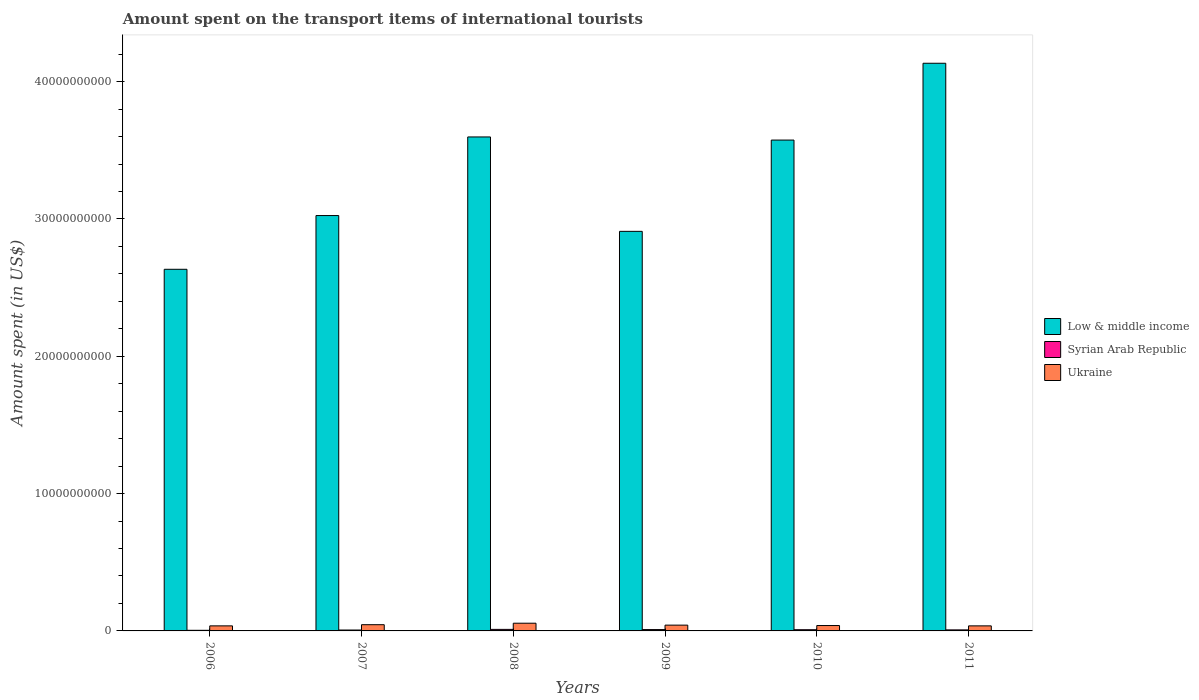Are the number of bars per tick equal to the number of legend labels?
Your response must be concise. Yes. What is the label of the 1st group of bars from the left?
Your response must be concise. 2006. In how many cases, is the number of bars for a given year not equal to the number of legend labels?
Make the answer very short. 0. What is the amount spent on the transport items of international tourists in Low & middle income in 2006?
Give a very brief answer. 2.63e+1. Across all years, what is the maximum amount spent on the transport items of international tourists in Syrian Arab Republic?
Provide a succinct answer. 1.12e+08. Across all years, what is the minimum amount spent on the transport items of international tourists in Ukraine?
Offer a terse response. 3.68e+08. What is the total amount spent on the transport items of international tourists in Ukraine in the graph?
Make the answer very short. 2.56e+09. What is the difference between the amount spent on the transport items of international tourists in Ukraine in 2006 and that in 2009?
Provide a short and direct response. -5.30e+07. What is the difference between the amount spent on the transport items of international tourists in Ukraine in 2008 and the amount spent on the transport items of international tourists in Syrian Arab Republic in 2009?
Make the answer very short. 4.64e+08. What is the average amount spent on the transport items of international tourists in Low & middle income per year?
Your answer should be very brief. 3.31e+1. In the year 2011, what is the difference between the amount spent on the transport items of international tourists in Ukraine and amount spent on the transport items of international tourists in Low & middle income?
Offer a terse response. -4.10e+1. What is the ratio of the amount spent on the transport items of international tourists in Ukraine in 2007 to that in 2009?
Offer a very short reply. 1.08. What is the difference between the highest and the second highest amount spent on the transport items of international tourists in Syrian Arab Republic?
Provide a short and direct response. 1.40e+07. What is the difference between the highest and the lowest amount spent on the transport items of international tourists in Low & middle income?
Provide a short and direct response. 1.50e+1. In how many years, is the amount spent on the transport items of international tourists in Ukraine greater than the average amount spent on the transport items of international tourists in Ukraine taken over all years?
Offer a very short reply. 2. Is the sum of the amount spent on the transport items of international tourists in Syrian Arab Republic in 2008 and 2009 greater than the maximum amount spent on the transport items of international tourists in Ukraine across all years?
Offer a very short reply. No. What does the 1st bar from the left in 2007 represents?
Give a very brief answer. Low & middle income. What does the 2nd bar from the right in 2011 represents?
Make the answer very short. Syrian Arab Republic. What is the difference between two consecutive major ticks on the Y-axis?
Provide a succinct answer. 1.00e+1. Are the values on the major ticks of Y-axis written in scientific E-notation?
Ensure brevity in your answer.  No. Does the graph contain any zero values?
Give a very brief answer. No. Where does the legend appear in the graph?
Offer a terse response. Center right. What is the title of the graph?
Keep it short and to the point. Amount spent on the transport items of international tourists. Does "Colombia" appear as one of the legend labels in the graph?
Ensure brevity in your answer.  No. What is the label or title of the Y-axis?
Provide a short and direct response. Amount spent (in US$). What is the Amount spent (in US$) in Low & middle income in 2006?
Your answer should be compact. 2.63e+1. What is the Amount spent (in US$) of Syrian Arab Republic in 2006?
Your response must be concise. 4.50e+07. What is the Amount spent (in US$) in Ukraine in 2006?
Your response must be concise. 3.68e+08. What is the Amount spent (in US$) of Low & middle income in 2007?
Offer a terse response. 3.02e+1. What is the Amount spent (in US$) in Syrian Arab Republic in 2007?
Keep it short and to the point. 6.50e+07. What is the Amount spent (in US$) of Ukraine in 2007?
Your response must be concise. 4.53e+08. What is the Amount spent (in US$) in Low & middle income in 2008?
Provide a succinct answer. 3.60e+1. What is the Amount spent (in US$) in Syrian Arab Republic in 2008?
Make the answer very short. 1.12e+08. What is the Amount spent (in US$) in Ukraine in 2008?
Provide a short and direct response. 5.62e+08. What is the Amount spent (in US$) of Low & middle income in 2009?
Provide a succinct answer. 2.91e+1. What is the Amount spent (in US$) in Syrian Arab Republic in 2009?
Give a very brief answer. 9.80e+07. What is the Amount spent (in US$) in Ukraine in 2009?
Give a very brief answer. 4.21e+08. What is the Amount spent (in US$) of Low & middle income in 2010?
Make the answer very short. 3.57e+1. What is the Amount spent (in US$) in Syrian Arab Republic in 2010?
Your response must be concise. 8.80e+07. What is the Amount spent (in US$) in Ukraine in 2010?
Provide a succinct answer. 3.92e+08. What is the Amount spent (in US$) in Low & middle income in 2011?
Ensure brevity in your answer.  4.13e+1. What is the Amount spent (in US$) of Syrian Arab Republic in 2011?
Offer a very short reply. 7.60e+07. What is the Amount spent (in US$) in Ukraine in 2011?
Make the answer very short. 3.68e+08. Across all years, what is the maximum Amount spent (in US$) in Low & middle income?
Your answer should be very brief. 4.13e+1. Across all years, what is the maximum Amount spent (in US$) in Syrian Arab Republic?
Give a very brief answer. 1.12e+08. Across all years, what is the maximum Amount spent (in US$) of Ukraine?
Your answer should be very brief. 5.62e+08. Across all years, what is the minimum Amount spent (in US$) of Low & middle income?
Give a very brief answer. 2.63e+1. Across all years, what is the minimum Amount spent (in US$) in Syrian Arab Republic?
Provide a succinct answer. 4.50e+07. Across all years, what is the minimum Amount spent (in US$) in Ukraine?
Your answer should be compact. 3.68e+08. What is the total Amount spent (in US$) of Low & middle income in the graph?
Give a very brief answer. 1.99e+11. What is the total Amount spent (in US$) of Syrian Arab Republic in the graph?
Your response must be concise. 4.84e+08. What is the total Amount spent (in US$) in Ukraine in the graph?
Ensure brevity in your answer.  2.56e+09. What is the difference between the Amount spent (in US$) in Low & middle income in 2006 and that in 2007?
Your answer should be very brief. -3.91e+09. What is the difference between the Amount spent (in US$) of Syrian Arab Republic in 2006 and that in 2007?
Give a very brief answer. -2.00e+07. What is the difference between the Amount spent (in US$) in Ukraine in 2006 and that in 2007?
Keep it short and to the point. -8.50e+07. What is the difference between the Amount spent (in US$) in Low & middle income in 2006 and that in 2008?
Your answer should be compact. -9.64e+09. What is the difference between the Amount spent (in US$) of Syrian Arab Republic in 2006 and that in 2008?
Keep it short and to the point. -6.70e+07. What is the difference between the Amount spent (in US$) in Ukraine in 2006 and that in 2008?
Offer a terse response. -1.94e+08. What is the difference between the Amount spent (in US$) in Low & middle income in 2006 and that in 2009?
Keep it short and to the point. -2.76e+09. What is the difference between the Amount spent (in US$) in Syrian Arab Republic in 2006 and that in 2009?
Make the answer very short. -5.30e+07. What is the difference between the Amount spent (in US$) of Ukraine in 2006 and that in 2009?
Your answer should be compact. -5.30e+07. What is the difference between the Amount spent (in US$) of Low & middle income in 2006 and that in 2010?
Your answer should be compact. -9.41e+09. What is the difference between the Amount spent (in US$) of Syrian Arab Republic in 2006 and that in 2010?
Your response must be concise. -4.30e+07. What is the difference between the Amount spent (in US$) in Ukraine in 2006 and that in 2010?
Provide a short and direct response. -2.40e+07. What is the difference between the Amount spent (in US$) of Low & middle income in 2006 and that in 2011?
Make the answer very short. -1.50e+1. What is the difference between the Amount spent (in US$) in Syrian Arab Republic in 2006 and that in 2011?
Keep it short and to the point. -3.10e+07. What is the difference between the Amount spent (in US$) of Ukraine in 2006 and that in 2011?
Keep it short and to the point. 0. What is the difference between the Amount spent (in US$) in Low & middle income in 2007 and that in 2008?
Provide a succinct answer. -5.72e+09. What is the difference between the Amount spent (in US$) of Syrian Arab Republic in 2007 and that in 2008?
Offer a terse response. -4.70e+07. What is the difference between the Amount spent (in US$) of Ukraine in 2007 and that in 2008?
Offer a terse response. -1.09e+08. What is the difference between the Amount spent (in US$) of Low & middle income in 2007 and that in 2009?
Your answer should be compact. 1.15e+09. What is the difference between the Amount spent (in US$) in Syrian Arab Republic in 2007 and that in 2009?
Provide a succinct answer. -3.30e+07. What is the difference between the Amount spent (in US$) in Ukraine in 2007 and that in 2009?
Keep it short and to the point. 3.20e+07. What is the difference between the Amount spent (in US$) of Low & middle income in 2007 and that in 2010?
Your answer should be very brief. -5.50e+09. What is the difference between the Amount spent (in US$) of Syrian Arab Republic in 2007 and that in 2010?
Your response must be concise. -2.30e+07. What is the difference between the Amount spent (in US$) of Ukraine in 2007 and that in 2010?
Give a very brief answer. 6.10e+07. What is the difference between the Amount spent (in US$) in Low & middle income in 2007 and that in 2011?
Your response must be concise. -1.11e+1. What is the difference between the Amount spent (in US$) in Syrian Arab Republic in 2007 and that in 2011?
Offer a very short reply. -1.10e+07. What is the difference between the Amount spent (in US$) in Ukraine in 2007 and that in 2011?
Give a very brief answer. 8.50e+07. What is the difference between the Amount spent (in US$) of Low & middle income in 2008 and that in 2009?
Keep it short and to the point. 6.88e+09. What is the difference between the Amount spent (in US$) of Syrian Arab Republic in 2008 and that in 2009?
Your answer should be very brief. 1.40e+07. What is the difference between the Amount spent (in US$) of Ukraine in 2008 and that in 2009?
Provide a succinct answer. 1.41e+08. What is the difference between the Amount spent (in US$) of Low & middle income in 2008 and that in 2010?
Provide a short and direct response. 2.28e+08. What is the difference between the Amount spent (in US$) in Syrian Arab Republic in 2008 and that in 2010?
Offer a terse response. 2.40e+07. What is the difference between the Amount spent (in US$) of Ukraine in 2008 and that in 2010?
Offer a very short reply. 1.70e+08. What is the difference between the Amount spent (in US$) in Low & middle income in 2008 and that in 2011?
Provide a succinct answer. -5.37e+09. What is the difference between the Amount spent (in US$) of Syrian Arab Republic in 2008 and that in 2011?
Make the answer very short. 3.60e+07. What is the difference between the Amount spent (in US$) in Ukraine in 2008 and that in 2011?
Make the answer very short. 1.94e+08. What is the difference between the Amount spent (in US$) in Low & middle income in 2009 and that in 2010?
Offer a terse response. -6.65e+09. What is the difference between the Amount spent (in US$) in Syrian Arab Republic in 2009 and that in 2010?
Provide a short and direct response. 1.00e+07. What is the difference between the Amount spent (in US$) in Ukraine in 2009 and that in 2010?
Your answer should be very brief. 2.90e+07. What is the difference between the Amount spent (in US$) of Low & middle income in 2009 and that in 2011?
Make the answer very short. -1.22e+1. What is the difference between the Amount spent (in US$) in Syrian Arab Republic in 2009 and that in 2011?
Ensure brevity in your answer.  2.20e+07. What is the difference between the Amount spent (in US$) in Ukraine in 2009 and that in 2011?
Offer a very short reply. 5.30e+07. What is the difference between the Amount spent (in US$) in Low & middle income in 2010 and that in 2011?
Your response must be concise. -5.59e+09. What is the difference between the Amount spent (in US$) of Ukraine in 2010 and that in 2011?
Offer a terse response. 2.40e+07. What is the difference between the Amount spent (in US$) of Low & middle income in 2006 and the Amount spent (in US$) of Syrian Arab Republic in 2007?
Your response must be concise. 2.63e+1. What is the difference between the Amount spent (in US$) of Low & middle income in 2006 and the Amount spent (in US$) of Ukraine in 2007?
Make the answer very short. 2.59e+1. What is the difference between the Amount spent (in US$) of Syrian Arab Republic in 2006 and the Amount spent (in US$) of Ukraine in 2007?
Provide a succinct answer. -4.08e+08. What is the difference between the Amount spent (in US$) of Low & middle income in 2006 and the Amount spent (in US$) of Syrian Arab Republic in 2008?
Your answer should be very brief. 2.62e+1. What is the difference between the Amount spent (in US$) of Low & middle income in 2006 and the Amount spent (in US$) of Ukraine in 2008?
Your answer should be compact. 2.58e+1. What is the difference between the Amount spent (in US$) of Syrian Arab Republic in 2006 and the Amount spent (in US$) of Ukraine in 2008?
Your answer should be very brief. -5.17e+08. What is the difference between the Amount spent (in US$) of Low & middle income in 2006 and the Amount spent (in US$) of Syrian Arab Republic in 2009?
Keep it short and to the point. 2.62e+1. What is the difference between the Amount spent (in US$) of Low & middle income in 2006 and the Amount spent (in US$) of Ukraine in 2009?
Provide a succinct answer. 2.59e+1. What is the difference between the Amount spent (in US$) of Syrian Arab Republic in 2006 and the Amount spent (in US$) of Ukraine in 2009?
Your response must be concise. -3.76e+08. What is the difference between the Amount spent (in US$) in Low & middle income in 2006 and the Amount spent (in US$) in Syrian Arab Republic in 2010?
Provide a succinct answer. 2.62e+1. What is the difference between the Amount spent (in US$) in Low & middle income in 2006 and the Amount spent (in US$) in Ukraine in 2010?
Your answer should be very brief. 2.59e+1. What is the difference between the Amount spent (in US$) of Syrian Arab Republic in 2006 and the Amount spent (in US$) of Ukraine in 2010?
Provide a short and direct response. -3.47e+08. What is the difference between the Amount spent (in US$) of Low & middle income in 2006 and the Amount spent (in US$) of Syrian Arab Republic in 2011?
Make the answer very short. 2.63e+1. What is the difference between the Amount spent (in US$) in Low & middle income in 2006 and the Amount spent (in US$) in Ukraine in 2011?
Make the answer very short. 2.60e+1. What is the difference between the Amount spent (in US$) in Syrian Arab Republic in 2006 and the Amount spent (in US$) in Ukraine in 2011?
Offer a terse response. -3.23e+08. What is the difference between the Amount spent (in US$) of Low & middle income in 2007 and the Amount spent (in US$) of Syrian Arab Republic in 2008?
Offer a very short reply. 3.01e+1. What is the difference between the Amount spent (in US$) of Low & middle income in 2007 and the Amount spent (in US$) of Ukraine in 2008?
Your response must be concise. 2.97e+1. What is the difference between the Amount spent (in US$) of Syrian Arab Republic in 2007 and the Amount spent (in US$) of Ukraine in 2008?
Your answer should be compact. -4.97e+08. What is the difference between the Amount spent (in US$) in Low & middle income in 2007 and the Amount spent (in US$) in Syrian Arab Republic in 2009?
Provide a short and direct response. 3.02e+1. What is the difference between the Amount spent (in US$) in Low & middle income in 2007 and the Amount spent (in US$) in Ukraine in 2009?
Provide a short and direct response. 2.98e+1. What is the difference between the Amount spent (in US$) of Syrian Arab Republic in 2007 and the Amount spent (in US$) of Ukraine in 2009?
Your answer should be compact. -3.56e+08. What is the difference between the Amount spent (in US$) of Low & middle income in 2007 and the Amount spent (in US$) of Syrian Arab Republic in 2010?
Keep it short and to the point. 3.02e+1. What is the difference between the Amount spent (in US$) of Low & middle income in 2007 and the Amount spent (in US$) of Ukraine in 2010?
Keep it short and to the point. 2.99e+1. What is the difference between the Amount spent (in US$) in Syrian Arab Republic in 2007 and the Amount spent (in US$) in Ukraine in 2010?
Offer a very short reply. -3.27e+08. What is the difference between the Amount spent (in US$) in Low & middle income in 2007 and the Amount spent (in US$) in Syrian Arab Republic in 2011?
Keep it short and to the point. 3.02e+1. What is the difference between the Amount spent (in US$) of Low & middle income in 2007 and the Amount spent (in US$) of Ukraine in 2011?
Provide a short and direct response. 2.99e+1. What is the difference between the Amount spent (in US$) in Syrian Arab Republic in 2007 and the Amount spent (in US$) in Ukraine in 2011?
Provide a succinct answer. -3.03e+08. What is the difference between the Amount spent (in US$) of Low & middle income in 2008 and the Amount spent (in US$) of Syrian Arab Republic in 2009?
Provide a succinct answer. 3.59e+1. What is the difference between the Amount spent (in US$) of Low & middle income in 2008 and the Amount spent (in US$) of Ukraine in 2009?
Offer a terse response. 3.56e+1. What is the difference between the Amount spent (in US$) of Syrian Arab Republic in 2008 and the Amount spent (in US$) of Ukraine in 2009?
Your answer should be compact. -3.09e+08. What is the difference between the Amount spent (in US$) in Low & middle income in 2008 and the Amount spent (in US$) in Syrian Arab Republic in 2010?
Offer a very short reply. 3.59e+1. What is the difference between the Amount spent (in US$) of Low & middle income in 2008 and the Amount spent (in US$) of Ukraine in 2010?
Offer a very short reply. 3.56e+1. What is the difference between the Amount spent (in US$) of Syrian Arab Republic in 2008 and the Amount spent (in US$) of Ukraine in 2010?
Ensure brevity in your answer.  -2.80e+08. What is the difference between the Amount spent (in US$) in Low & middle income in 2008 and the Amount spent (in US$) in Syrian Arab Republic in 2011?
Make the answer very short. 3.59e+1. What is the difference between the Amount spent (in US$) in Low & middle income in 2008 and the Amount spent (in US$) in Ukraine in 2011?
Keep it short and to the point. 3.56e+1. What is the difference between the Amount spent (in US$) in Syrian Arab Republic in 2008 and the Amount spent (in US$) in Ukraine in 2011?
Provide a short and direct response. -2.56e+08. What is the difference between the Amount spent (in US$) in Low & middle income in 2009 and the Amount spent (in US$) in Syrian Arab Republic in 2010?
Provide a succinct answer. 2.90e+1. What is the difference between the Amount spent (in US$) in Low & middle income in 2009 and the Amount spent (in US$) in Ukraine in 2010?
Ensure brevity in your answer.  2.87e+1. What is the difference between the Amount spent (in US$) of Syrian Arab Republic in 2009 and the Amount spent (in US$) of Ukraine in 2010?
Your response must be concise. -2.94e+08. What is the difference between the Amount spent (in US$) in Low & middle income in 2009 and the Amount spent (in US$) in Syrian Arab Republic in 2011?
Give a very brief answer. 2.90e+1. What is the difference between the Amount spent (in US$) in Low & middle income in 2009 and the Amount spent (in US$) in Ukraine in 2011?
Keep it short and to the point. 2.87e+1. What is the difference between the Amount spent (in US$) of Syrian Arab Republic in 2009 and the Amount spent (in US$) of Ukraine in 2011?
Make the answer very short. -2.70e+08. What is the difference between the Amount spent (in US$) in Low & middle income in 2010 and the Amount spent (in US$) in Syrian Arab Republic in 2011?
Your response must be concise. 3.57e+1. What is the difference between the Amount spent (in US$) of Low & middle income in 2010 and the Amount spent (in US$) of Ukraine in 2011?
Give a very brief answer. 3.54e+1. What is the difference between the Amount spent (in US$) of Syrian Arab Republic in 2010 and the Amount spent (in US$) of Ukraine in 2011?
Make the answer very short. -2.80e+08. What is the average Amount spent (in US$) of Low & middle income per year?
Give a very brief answer. 3.31e+1. What is the average Amount spent (in US$) of Syrian Arab Republic per year?
Ensure brevity in your answer.  8.07e+07. What is the average Amount spent (in US$) of Ukraine per year?
Your response must be concise. 4.27e+08. In the year 2006, what is the difference between the Amount spent (in US$) in Low & middle income and Amount spent (in US$) in Syrian Arab Republic?
Keep it short and to the point. 2.63e+1. In the year 2006, what is the difference between the Amount spent (in US$) in Low & middle income and Amount spent (in US$) in Ukraine?
Ensure brevity in your answer.  2.60e+1. In the year 2006, what is the difference between the Amount spent (in US$) of Syrian Arab Republic and Amount spent (in US$) of Ukraine?
Provide a short and direct response. -3.23e+08. In the year 2007, what is the difference between the Amount spent (in US$) of Low & middle income and Amount spent (in US$) of Syrian Arab Republic?
Your answer should be very brief. 3.02e+1. In the year 2007, what is the difference between the Amount spent (in US$) of Low & middle income and Amount spent (in US$) of Ukraine?
Make the answer very short. 2.98e+1. In the year 2007, what is the difference between the Amount spent (in US$) of Syrian Arab Republic and Amount spent (in US$) of Ukraine?
Provide a short and direct response. -3.88e+08. In the year 2008, what is the difference between the Amount spent (in US$) in Low & middle income and Amount spent (in US$) in Syrian Arab Republic?
Ensure brevity in your answer.  3.59e+1. In the year 2008, what is the difference between the Amount spent (in US$) of Low & middle income and Amount spent (in US$) of Ukraine?
Your answer should be very brief. 3.54e+1. In the year 2008, what is the difference between the Amount spent (in US$) in Syrian Arab Republic and Amount spent (in US$) in Ukraine?
Ensure brevity in your answer.  -4.50e+08. In the year 2009, what is the difference between the Amount spent (in US$) of Low & middle income and Amount spent (in US$) of Syrian Arab Republic?
Ensure brevity in your answer.  2.90e+1. In the year 2009, what is the difference between the Amount spent (in US$) of Low & middle income and Amount spent (in US$) of Ukraine?
Ensure brevity in your answer.  2.87e+1. In the year 2009, what is the difference between the Amount spent (in US$) in Syrian Arab Republic and Amount spent (in US$) in Ukraine?
Your response must be concise. -3.23e+08. In the year 2010, what is the difference between the Amount spent (in US$) in Low & middle income and Amount spent (in US$) in Syrian Arab Republic?
Keep it short and to the point. 3.57e+1. In the year 2010, what is the difference between the Amount spent (in US$) of Low & middle income and Amount spent (in US$) of Ukraine?
Provide a succinct answer. 3.54e+1. In the year 2010, what is the difference between the Amount spent (in US$) of Syrian Arab Republic and Amount spent (in US$) of Ukraine?
Provide a short and direct response. -3.04e+08. In the year 2011, what is the difference between the Amount spent (in US$) of Low & middle income and Amount spent (in US$) of Syrian Arab Republic?
Make the answer very short. 4.13e+1. In the year 2011, what is the difference between the Amount spent (in US$) in Low & middle income and Amount spent (in US$) in Ukraine?
Your answer should be compact. 4.10e+1. In the year 2011, what is the difference between the Amount spent (in US$) of Syrian Arab Republic and Amount spent (in US$) of Ukraine?
Your answer should be compact. -2.92e+08. What is the ratio of the Amount spent (in US$) of Low & middle income in 2006 to that in 2007?
Keep it short and to the point. 0.87. What is the ratio of the Amount spent (in US$) in Syrian Arab Republic in 2006 to that in 2007?
Provide a succinct answer. 0.69. What is the ratio of the Amount spent (in US$) of Ukraine in 2006 to that in 2007?
Offer a terse response. 0.81. What is the ratio of the Amount spent (in US$) of Low & middle income in 2006 to that in 2008?
Offer a terse response. 0.73. What is the ratio of the Amount spent (in US$) in Syrian Arab Republic in 2006 to that in 2008?
Give a very brief answer. 0.4. What is the ratio of the Amount spent (in US$) in Ukraine in 2006 to that in 2008?
Provide a succinct answer. 0.65. What is the ratio of the Amount spent (in US$) in Low & middle income in 2006 to that in 2009?
Keep it short and to the point. 0.91. What is the ratio of the Amount spent (in US$) of Syrian Arab Republic in 2006 to that in 2009?
Ensure brevity in your answer.  0.46. What is the ratio of the Amount spent (in US$) of Ukraine in 2006 to that in 2009?
Your answer should be compact. 0.87. What is the ratio of the Amount spent (in US$) in Low & middle income in 2006 to that in 2010?
Offer a terse response. 0.74. What is the ratio of the Amount spent (in US$) of Syrian Arab Republic in 2006 to that in 2010?
Your answer should be very brief. 0.51. What is the ratio of the Amount spent (in US$) of Ukraine in 2006 to that in 2010?
Provide a short and direct response. 0.94. What is the ratio of the Amount spent (in US$) in Low & middle income in 2006 to that in 2011?
Provide a succinct answer. 0.64. What is the ratio of the Amount spent (in US$) in Syrian Arab Republic in 2006 to that in 2011?
Offer a terse response. 0.59. What is the ratio of the Amount spent (in US$) of Low & middle income in 2007 to that in 2008?
Give a very brief answer. 0.84. What is the ratio of the Amount spent (in US$) of Syrian Arab Republic in 2007 to that in 2008?
Your response must be concise. 0.58. What is the ratio of the Amount spent (in US$) in Ukraine in 2007 to that in 2008?
Your answer should be compact. 0.81. What is the ratio of the Amount spent (in US$) of Low & middle income in 2007 to that in 2009?
Provide a short and direct response. 1.04. What is the ratio of the Amount spent (in US$) of Syrian Arab Republic in 2007 to that in 2009?
Your answer should be compact. 0.66. What is the ratio of the Amount spent (in US$) in Ukraine in 2007 to that in 2009?
Provide a short and direct response. 1.08. What is the ratio of the Amount spent (in US$) of Low & middle income in 2007 to that in 2010?
Offer a terse response. 0.85. What is the ratio of the Amount spent (in US$) in Syrian Arab Republic in 2007 to that in 2010?
Give a very brief answer. 0.74. What is the ratio of the Amount spent (in US$) of Ukraine in 2007 to that in 2010?
Your response must be concise. 1.16. What is the ratio of the Amount spent (in US$) in Low & middle income in 2007 to that in 2011?
Provide a succinct answer. 0.73. What is the ratio of the Amount spent (in US$) in Syrian Arab Republic in 2007 to that in 2011?
Provide a succinct answer. 0.86. What is the ratio of the Amount spent (in US$) of Ukraine in 2007 to that in 2011?
Ensure brevity in your answer.  1.23. What is the ratio of the Amount spent (in US$) in Low & middle income in 2008 to that in 2009?
Provide a succinct answer. 1.24. What is the ratio of the Amount spent (in US$) in Syrian Arab Republic in 2008 to that in 2009?
Your answer should be compact. 1.14. What is the ratio of the Amount spent (in US$) of Ukraine in 2008 to that in 2009?
Make the answer very short. 1.33. What is the ratio of the Amount spent (in US$) in Low & middle income in 2008 to that in 2010?
Your response must be concise. 1.01. What is the ratio of the Amount spent (in US$) in Syrian Arab Republic in 2008 to that in 2010?
Ensure brevity in your answer.  1.27. What is the ratio of the Amount spent (in US$) in Ukraine in 2008 to that in 2010?
Make the answer very short. 1.43. What is the ratio of the Amount spent (in US$) in Low & middle income in 2008 to that in 2011?
Your answer should be very brief. 0.87. What is the ratio of the Amount spent (in US$) in Syrian Arab Republic in 2008 to that in 2011?
Make the answer very short. 1.47. What is the ratio of the Amount spent (in US$) of Ukraine in 2008 to that in 2011?
Offer a terse response. 1.53. What is the ratio of the Amount spent (in US$) in Low & middle income in 2009 to that in 2010?
Keep it short and to the point. 0.81. What is the ratio of the Amount spent (in US$) in Syrian Arab Republic in 2009 to that in 2010?
Ensure brevity in your answer.  1.11. What is the ratio of the Amount spent (in US$) of Ukraine in 2009 to that in 2010?
Provide a succinct answer. 1.07. What is the ratio of the Amount spent (in US$) in Low & middle income in 2009 to that in 2011?
Provide a short and direct response. 0.7. What is the ratio of the Amount spent (in US$) in Syrian Arab Republic in 2009 to that in 2011?
Your answer should be very brief. 1.29. What is the ratio of the Amount spent (in US$) of Ukraine in 2009 to that in 2011?
Give a very brief answer. 1.14. What is the ratio of the Amount spent (in US$) of Low & middle income in 2010 to that in 2011?
Keep it short and to the point. 0.86. What is the ratio of the Amount spent (in US$) in Syrian Arab Republic in 2010 to that in 2011?
Ensure brevity in your answer.  1.16. What is the ratio of the Amount spent (in US$) of Ukraine in 2010 to that in 2011?
Give a very brief answer. 1.07. What is the difference between the highest and the second highest Amount spent (in US$) in Low & middle income?
Your answer should be very brief. 5.37e+09. What is the difference between the highest and the second highest Amount spent (in US$) in Syrian Arab Republic?
Make the answer very short. 1.40e+07. What is the difference between the highest and the second highest Amount spent (in US$) in Ukraine?
Your response must be concise. 1.09e+08. What is the difference between the highest and the lowest Amount spent (in US$) of Low & middle income?
Offer a terse response. 1.50e+1. What is the difference between the highest and the lowest Amount spent (in US$) of Syrian Arab Republic?
Offer a very short reply. 6.70e+07. What is the difference between the highest and the lowest Amount spent (in US$) of Ukraine?
Offer a terse response. 1.94e+08. 